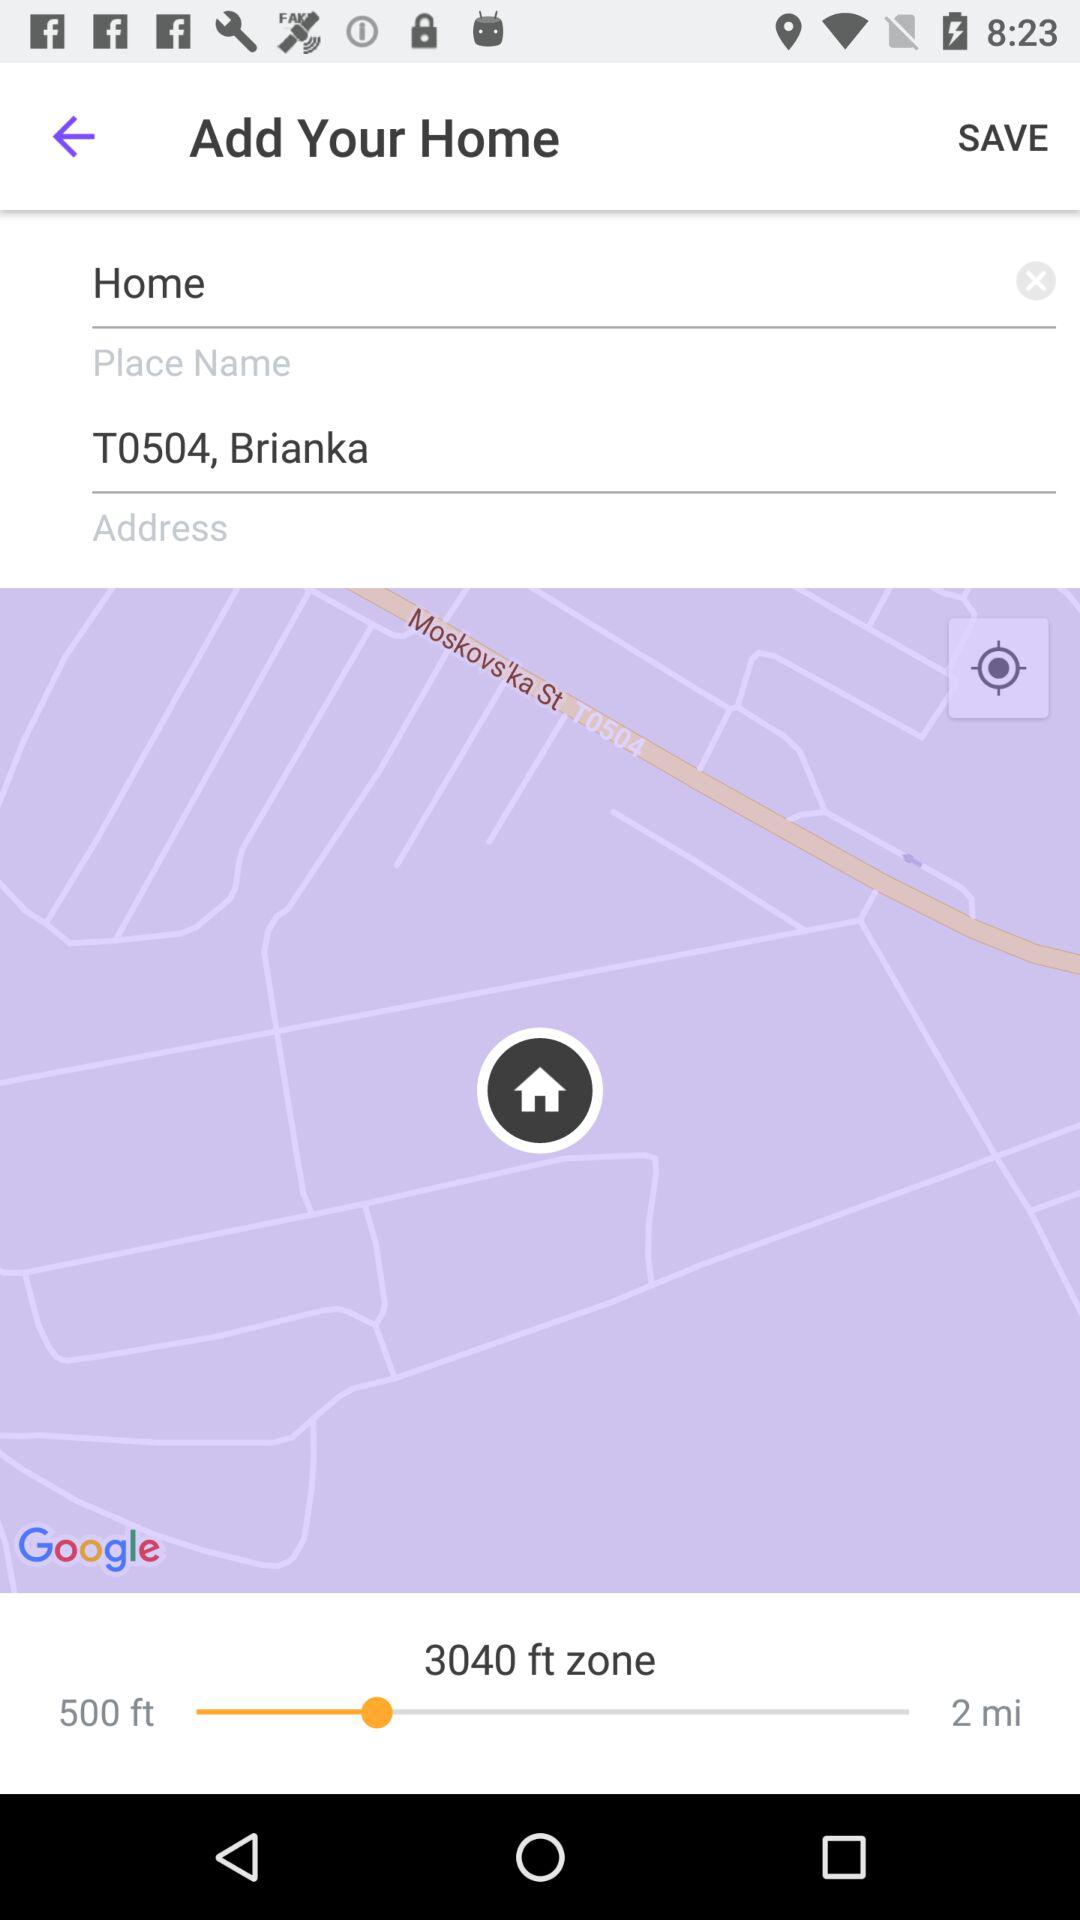What is the place name? The place name is Home. 